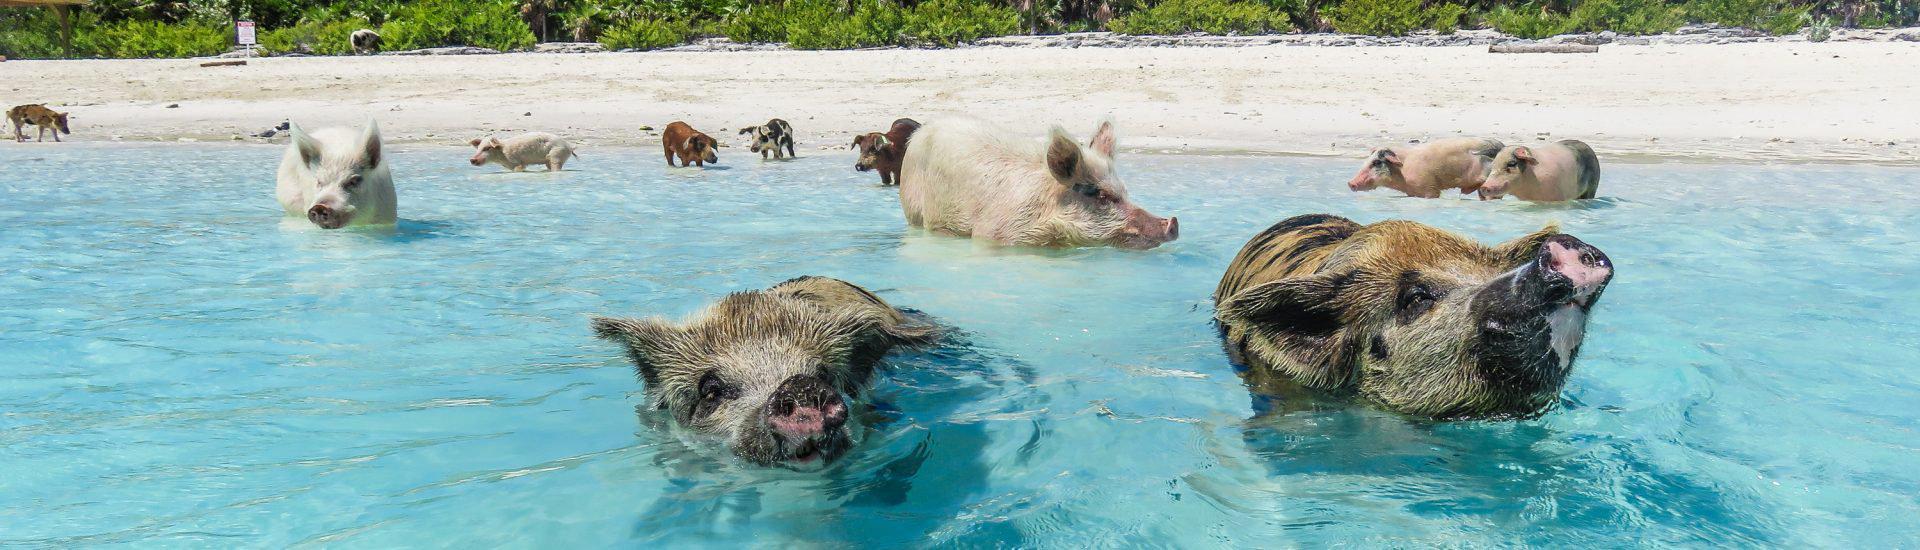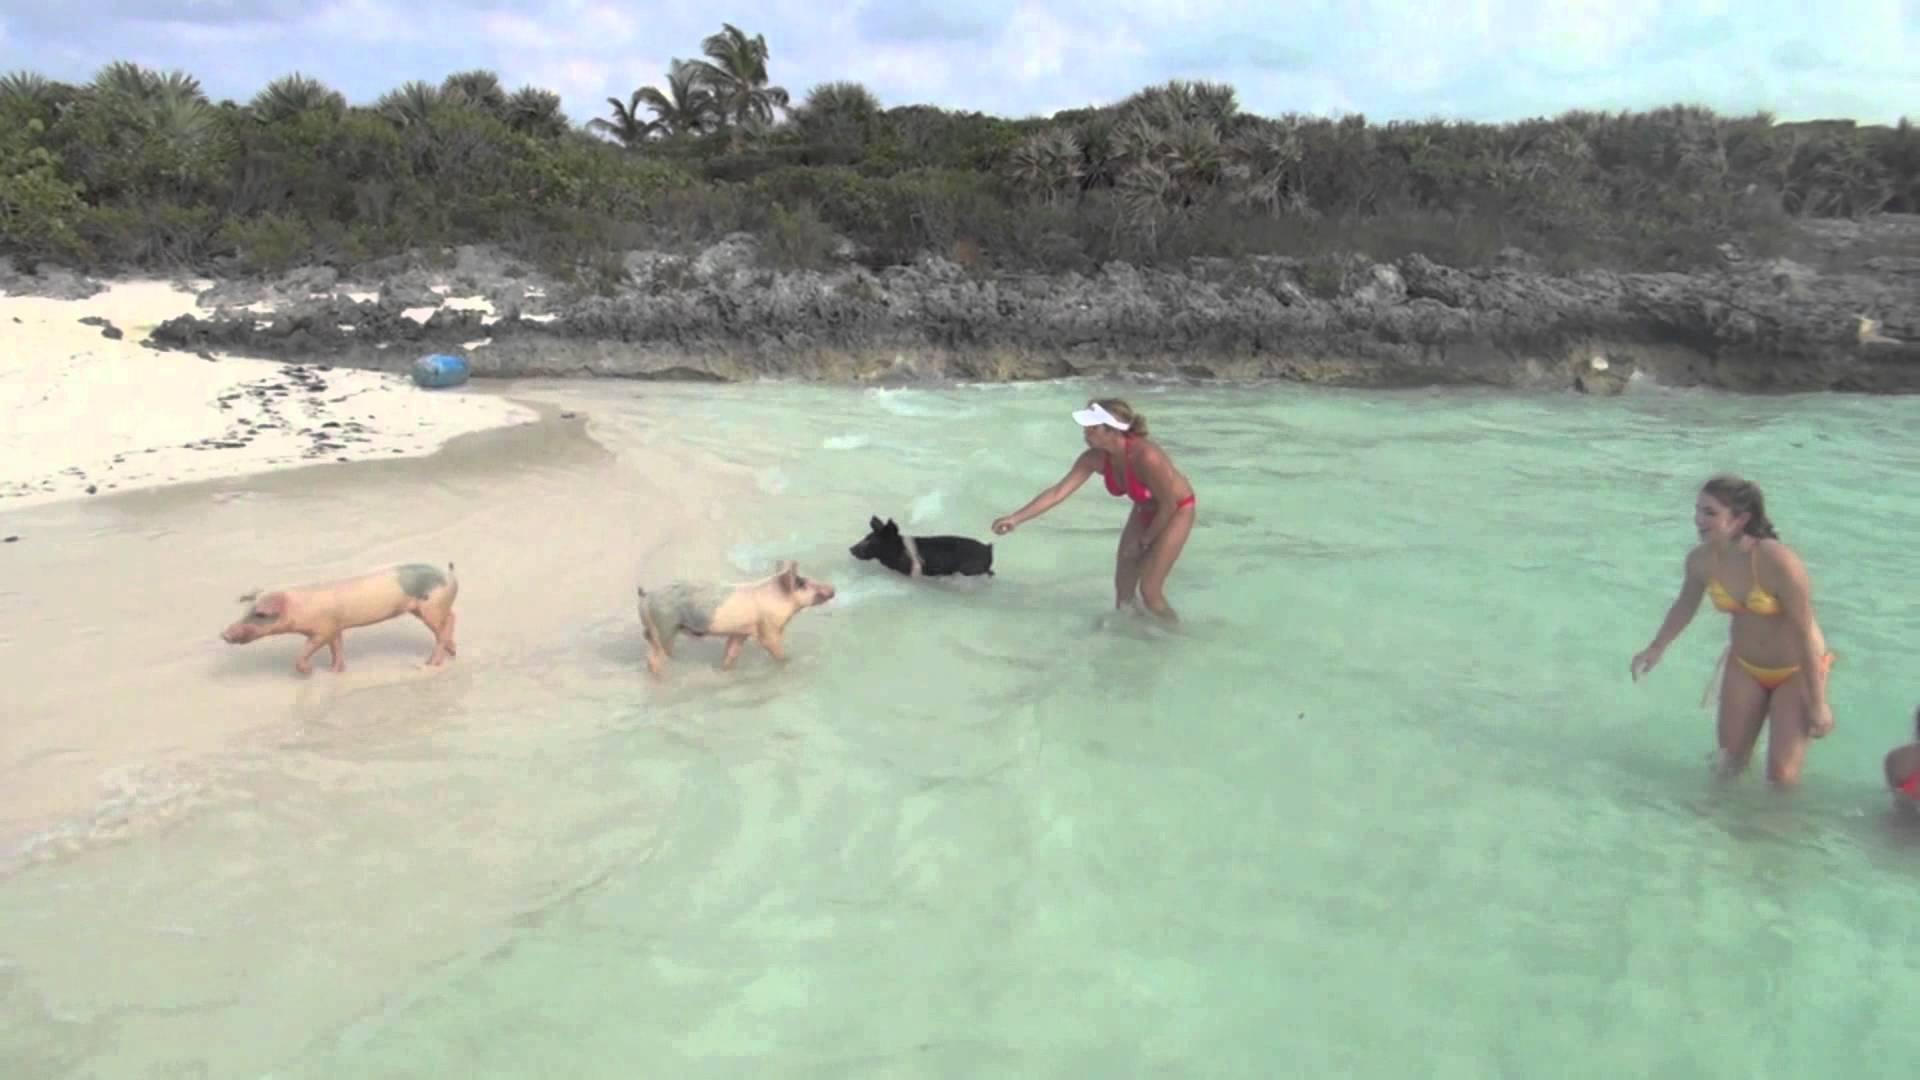The first image is the image on the left, the second image is the image on the right. Assess this claim about the two images: "There is one pig in the right image.". Correct or not? Answer yes or no. No. The first image is the image on the left, the second image is the image on the right. Assess this claim about the two images: "The right image contains exactly one spotted pig, which is viewed from above and swimming toward the camera.". Correct or not? Answer yes or no. No. 